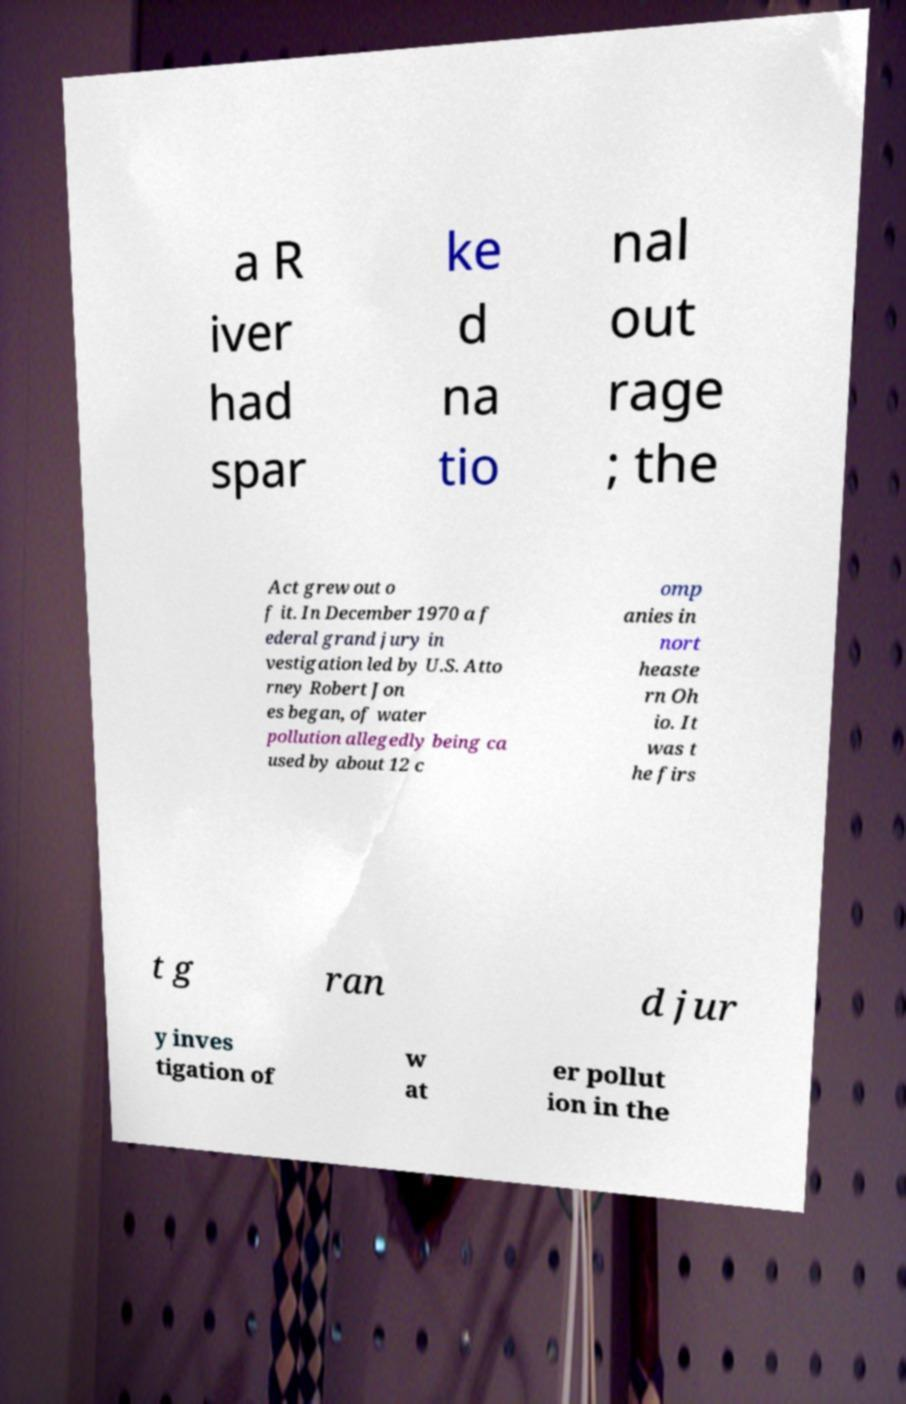There's text embedded in this image that I need extracted. Can you transcribe it verbatim? a R iver had spar ke d na tio nal out rage ; the Act grew out o f it. In December 1970 a f ederal grand jury in vestigation led by U.S. Atto rney Robert Jon es began, of water pollution allegedly being ca used by about 12 c omp anies in nort heaste rn Oh io. It was t he firs t g ran d jur y inves tigation of w at er pollut ion in the 